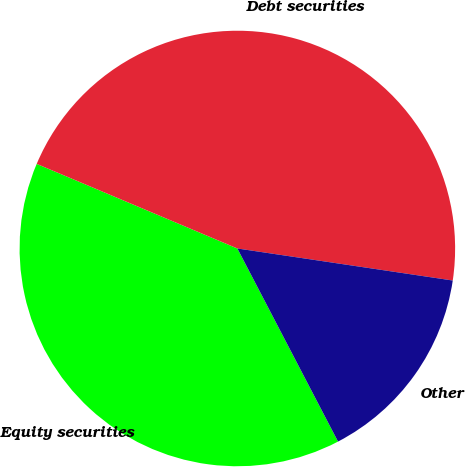Convert chart. <chart><loc_0><loc_0><loc_500><loc_500><pie_chart><fcel>Equity securities<fcel>Debt securities<fcel>Other<nl><fcel>39.0%<fcel>46.0%<fcel>15.0%<nl></chart> 